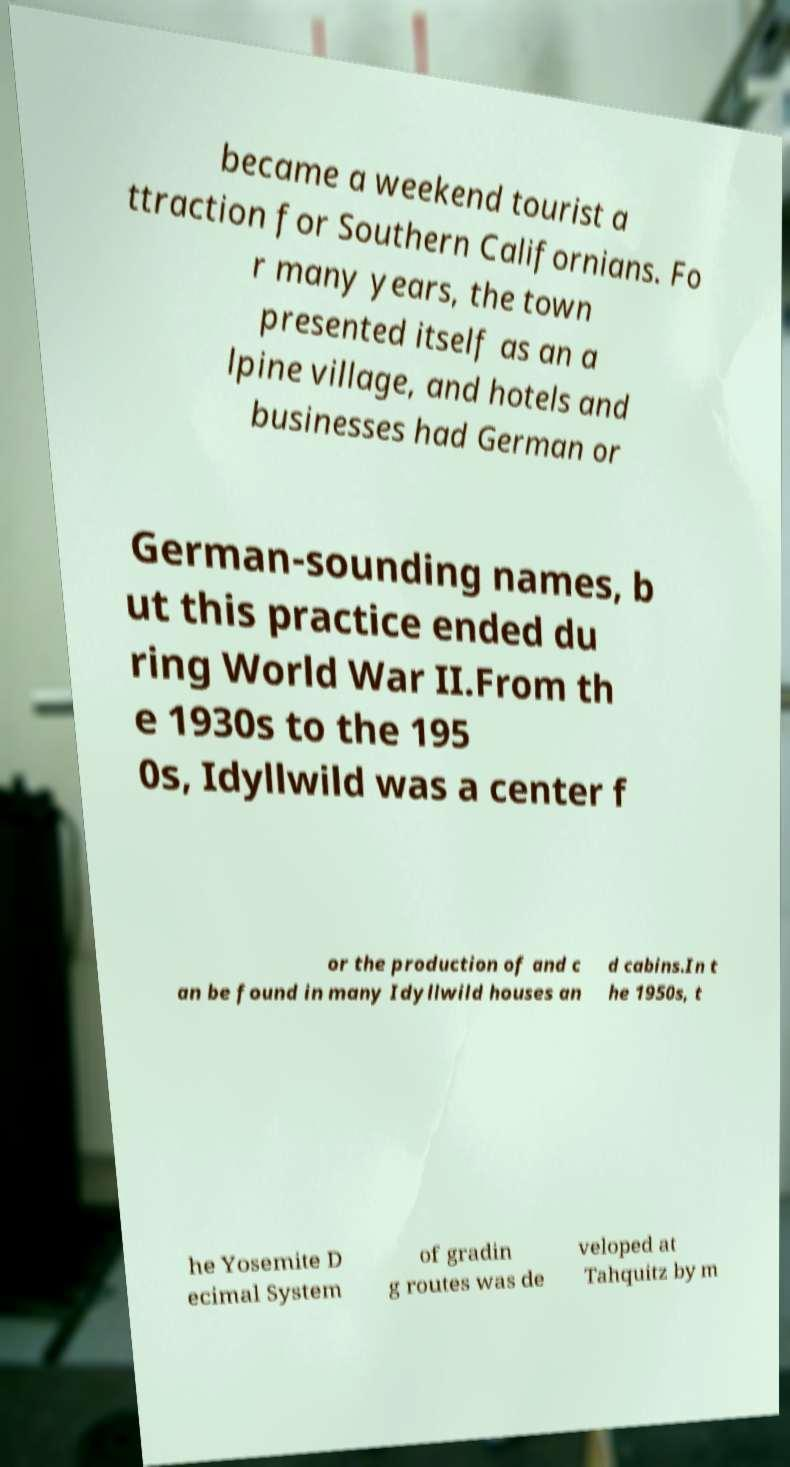Please read and relay the text visible in this image. What does it say? became a weekend tourist a ttraction for Southern Californians. Fo r many years, the town presented itself as an a lpine village, and hotels and businesses had German or German-sounding names, b ut this practice ended du ring World War II.From th e 1930s to the 195 0s, Idyllwild was a center f or the production of and c an be found in many Idyllwild houses an d cabins.In t he 1950s, t he Yosemite D ecimal System of gradin g routes was de veloped at Tahquitz by m 